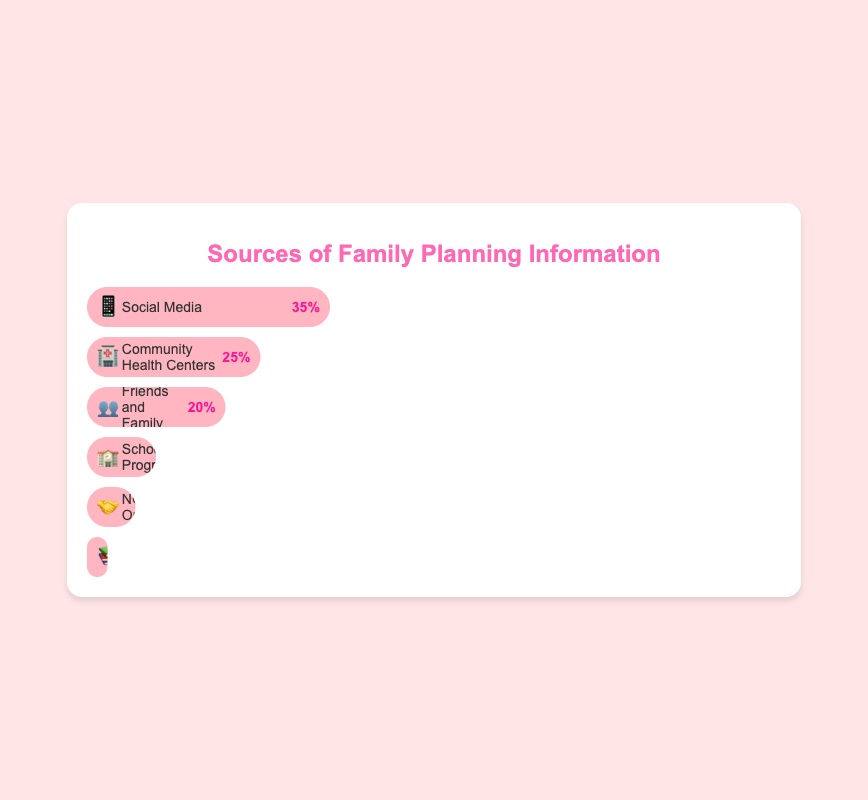Which source of family planning information has the highest percentage? The Social Media 📱 bar reaches 35%, which is the highest among all the sources listed in the figure.
Answer: Social Media 📱 What is the total percentage of family planning information acquired from social sources (Friends and Family 👥 and Social Media 📱)? Add the percentages for Friends and Family 👥 (20%) and Social Media 📱 (35%) together: 20% + 35% = 55%.
Answer: 55% Which source has a lower percentage, NGO Outreach 🤝 or Books and Pamphlets 📚? The percentage for NGO Outreach 🤝 is 7%, and for Books and Pamphlets 📚, it is 3%. Since 3% is lower than 7%, Books and Pamphlets 📚 have a lower percentage.
Answer: Books and Pamphlets 📚 How much greater is the percentage of family planning information from Community Health Centers 🏥 compared to School Programs 🏫? Subtract the percentage for School Programs 🏫 (10%) from Community Health Centers 🏥 (25%): 25% - 10% = 15%.
Answer: 15% Which source of family planning information received the least attention? The Books and Pamphlets 📚 bar is the shortest, indicating it has the smallest percentage at 3%.
Answer: Books and Pamphlets 📚 What is the combined percentage for School Programs 🏫, NGO Outreach 🤝, and Books and Pamphlets 📚? Sum the percentages: School Programs 🏫 (10%), NGO Outreach 🤝 (7%), and Books and Pamphlets 📚 (3%): 10% + 7% + 3% = 20%.
Answer: 20% Compare the popularity between Community Health Centers 🏥 and Friends and Family 👥. Which is more preferred and by how much? The percentage for Community Health Centers 🏥 is 25%, while for Friends and Family 👥, it is 20%. Community Health Centers 🏥 are preferred by 5% more.
Answer: Community Health Centers 🏥 by 5% What is the average percentage of the top three information sources? The top three sources are Social Media 📱 (35%), Community Health Centers 🏥 (25%), and Friends and Family 👥 (20%). Sum these percentages and divide by three: (35% + 25% + 20%) / 3 = 80% / 3 ≈ 26.67%.
Answer: Approximately 26.67% 